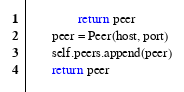Convert code to text. <code><loc_0><loc_0><loc_500><loc_500><_Python_>                return peer
        peer = Peer(host, port)
        self.peers.append(peer)
        return peer
</code> 